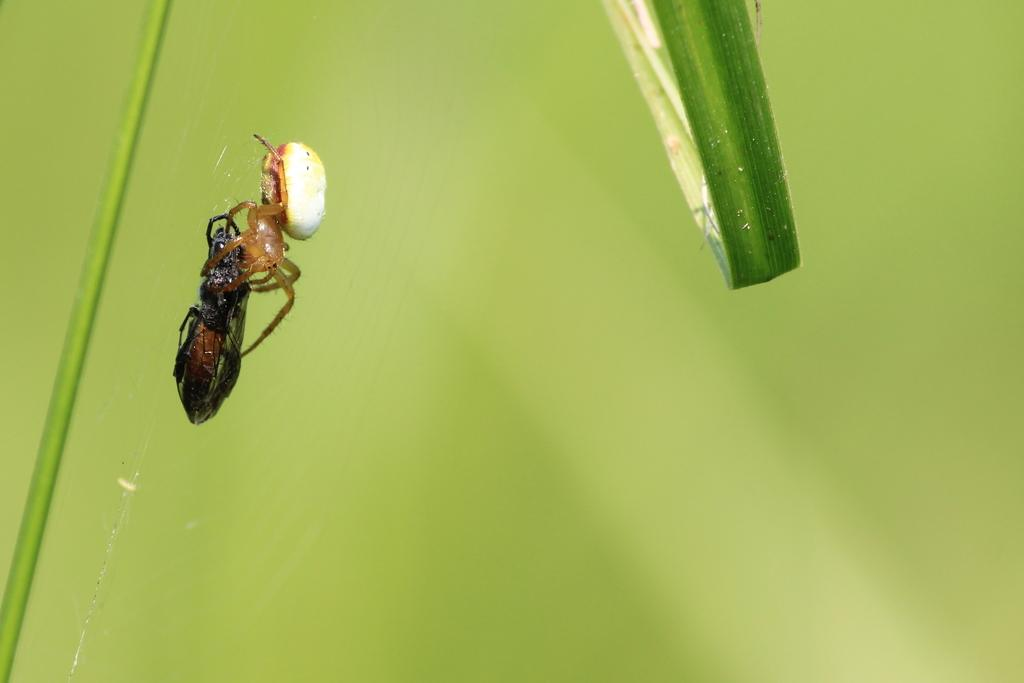What is present in the image? There is an insect in the image. Where is the insect located? The insect is on a leaf. What type of wool is being used by the insect's owner in the image? There is no wool or owner present in the image; it features an insect on a leaf. 